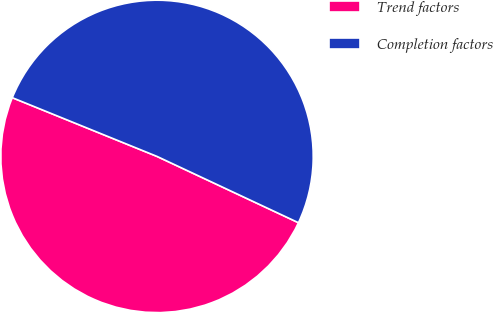Convert chart to OTSL. <chart><loc_0><loc_0><loc_500><loc_500><pie_chart><fcel>Trend factors<fcel>Completion factors<nl><fcel>49.16%<fcel>50.84%<nl></chart> 